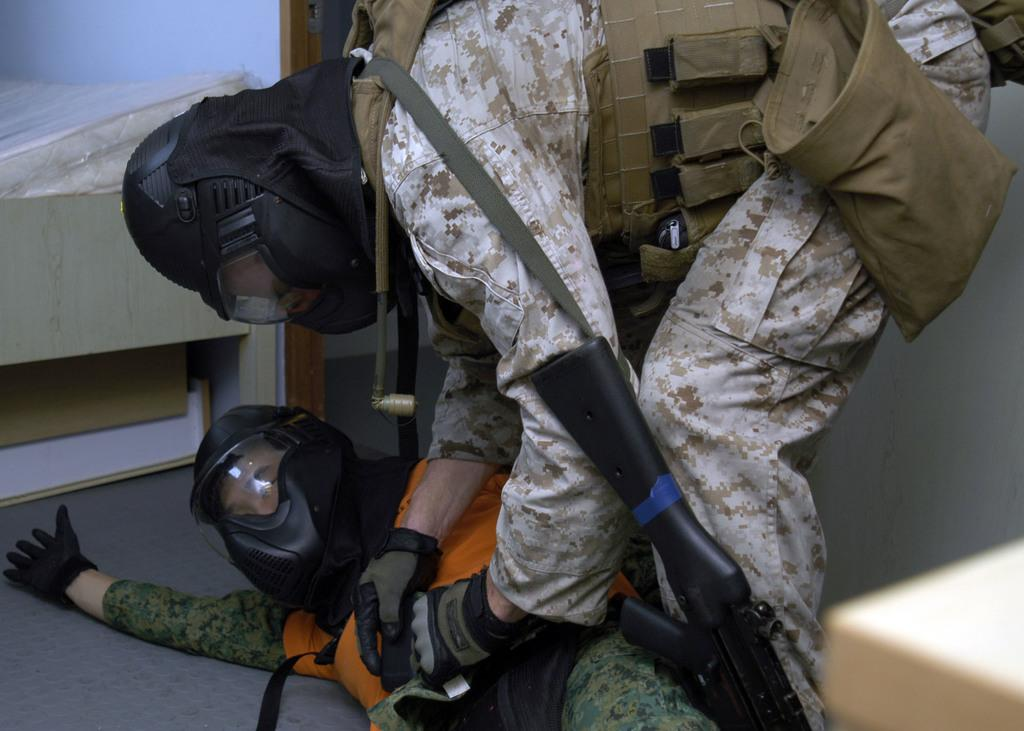How many people are in the image? There are two people in the image. What are the people wearing? The people are wearing uniforms. What are the people carrying? The people are carrying bags. What are the people holding in their hands? The people are holding guns. What type of furniture can be seen in the image? There is a bed, a box under the bed, and a desk in the image. What type of fuel is being used by the people in the image? There is no mention of fuel or any fuel-related objects in the image. What kind of breakfast is being prepared on the desk in the image? There is no indication of any food or cooking activity in the image. 